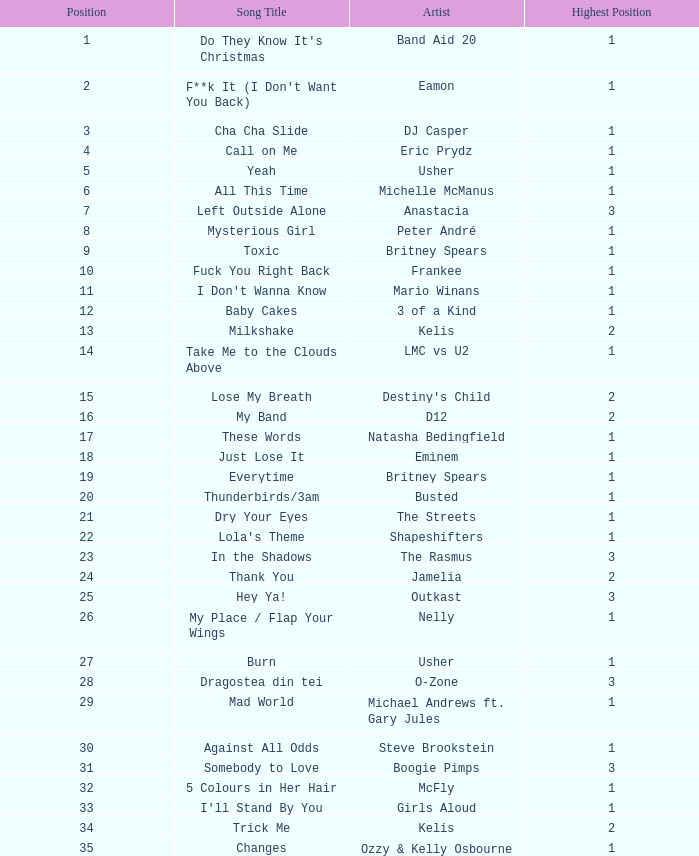What were the earnings for dj casper when he held a spot lower than 13? 351421.0. Would you mind parsing the complete table? {'header': ['Position', 'Song Title', 'Artist', 'Highest Position'], 'rows': [['1', "Do They Know It's Christmas", 'Band Aid 20', '1'], ['2', "F**k It (I Don't Want You Back)", 'Eamon', '1'], ['3', 'Cha Cha Slide', 'DJ Casper', '1'], ['4', 'Call on Me', 'Eric Prydz', '1'], ['5', 'Yeah', 'Usher', '1'], ['6', 'All This Time', 'Michelle McManus', '1'], ['7', 'Left Outside Alone', 'Anastacia', '3'], ['8', 'Mysterious Girl', 'Peter André', '1'], ['9', 'Toxic', 'Britney Spears', '1'], ['10', 'Fuck You Right Back', 'Frankee', '1'], ['11', "I Don't Wanna Know", 'Mario Winans', '1'], ['12', 'Baby Cakes', '3 of a Kind', '1'], ['13', 'Milkshake', 'Kelis', '2'], ['14', 'Take Me to the Clouds Above', 'LMC vs U2', '1'], ['15', 'Lose My Breath', "Destiny's Child", '2'], ['16', 'My Band', 'D12', '2'], ['17', 'These Words', 'Natasha Bedingfield', '1'], ['18', 'Just Lose It', 'Eminem', '1'], ['19', 'Everytime', 'Britney Spears', '1'], ['20', 'Thunderbirds/3am', 'Busted', '1'], ['21', 'Dry Your Eyes', 'The Streets', '1'], ['22', "Lola's Theme", 'Shapeshifters', '1'], ['23', 'In the Shadows', 'The Rasmus', '3'], ['24', 'Thank You', 'Jamelia', '2'], ['25', 'Hey Ya!', 'Outkast', '3'], ['26', 'My Place / Flap Your Wings', 'Nelly', '1'], ['27', 'Burn', 'Usher', '1'], ['28', 'Dragostea din tei', 'O-Zone', '3'], ['29', 'Mad World', 'Michael Andrews ft. Gary Jules', '1'], ['30', 'Against All Odds', 'Steve Brookstein', '1'], ['31', 'Somebody to Love', 'Boogie Pimps', '3'], ['32', '5 Colours in Her Hair', 'McFly', '1'], ['33', "I'll Stand By You", 'Girls Aloud', '1'], ['34', 'Trick Me', 'Kelis', '2'], ['35', 'Changes', 'Ozzy & Kelly Osbourne', '1'], ['36', 'Leave (Get Out)', 'JoJo', '2'], ['37', 'Dip It Low', 'Christina Milian', '2'], ['38', 'Hotel', 'Cassidy', '3'], ['39', 'This Love', 'Maroon 5', '3'], ['40', 'Some Girls', 'Rachel Stevens', '2']]} 